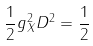Convert formula to latex. <formula><loc_0><loc_0><loc_500><loc_500>\frac { 1 } { 2 } g _ { X } ^ { 2 } D ^ { 2 } = \frac { 1 } { 2 }</formula> 